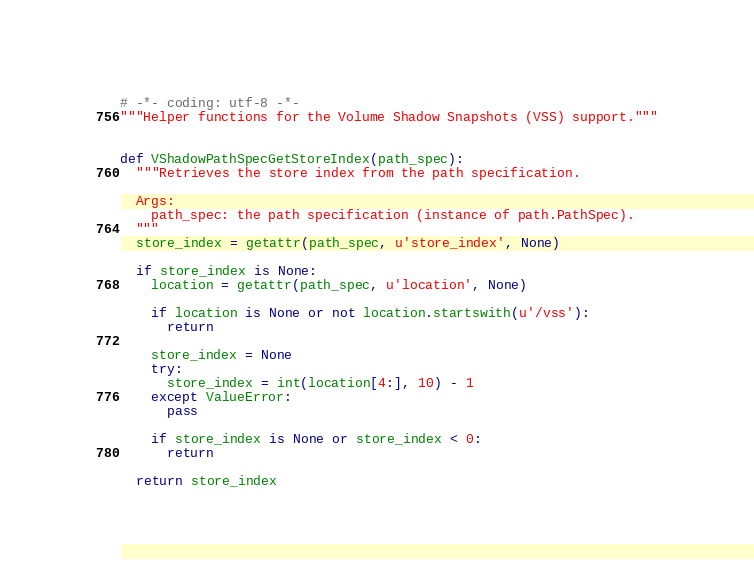<code> <loc_0><loc_0><loc_500><loc_500><_Python_># -*- coding: utf-8 -*-
"""Helper functions for the Volume Shadow Snapshots (VSS) support."""


def VShadowPathSpecGetStoreIndex(path_spec):
  """Retrieves the store index from the path specification.

  Args:
    path_spec: the path specification (instance of path.PathSpec).
  """
  store_index = getattr(path_spec, u'store_index', None)

  if store_index is None:
    location = getattr(path_spec, u'location', None)

    if location is None or not location.startswith(u'/vss'):
      return

    store_index = None
    try:
      store_index = int(location[4:], 10) - 1
    except ValueError:
      pass

    if store_index is None or store_index < 0:
      return

  return store_index
</code> 